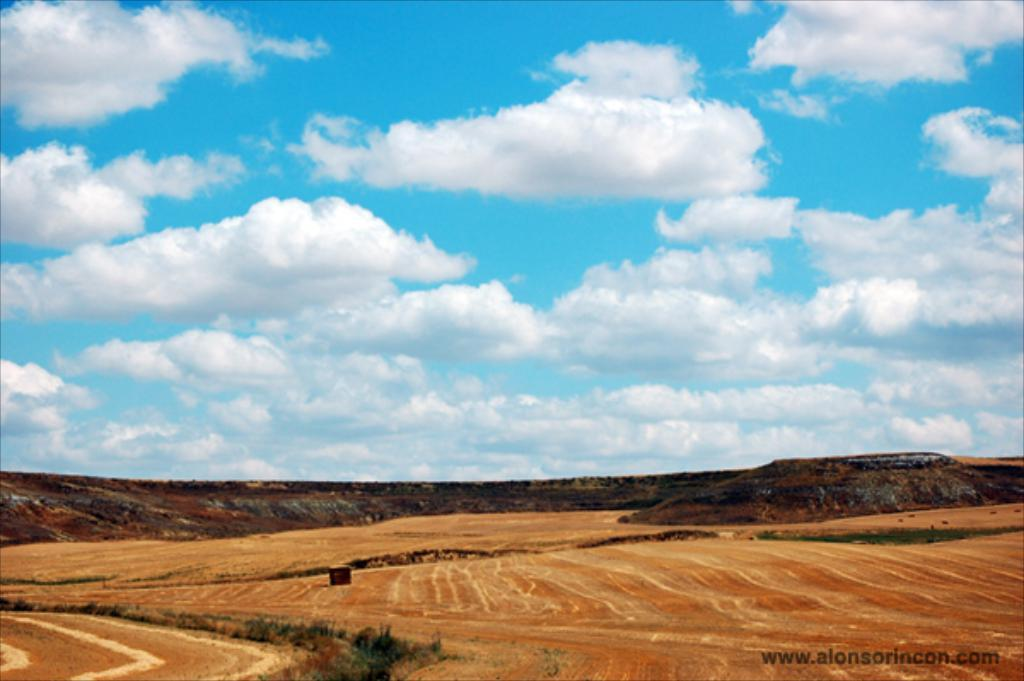What type of landscape is visible at the bottom of the picture? Fields, trees, and hills are visible at the bottom of the picture. What is the weather like in the image? The sky is sunny in the image. What type of silver object can be seen blowing in the wind at the bottom of the picture? There is no silver object present in the image, and therefore no such activity can be observed. 